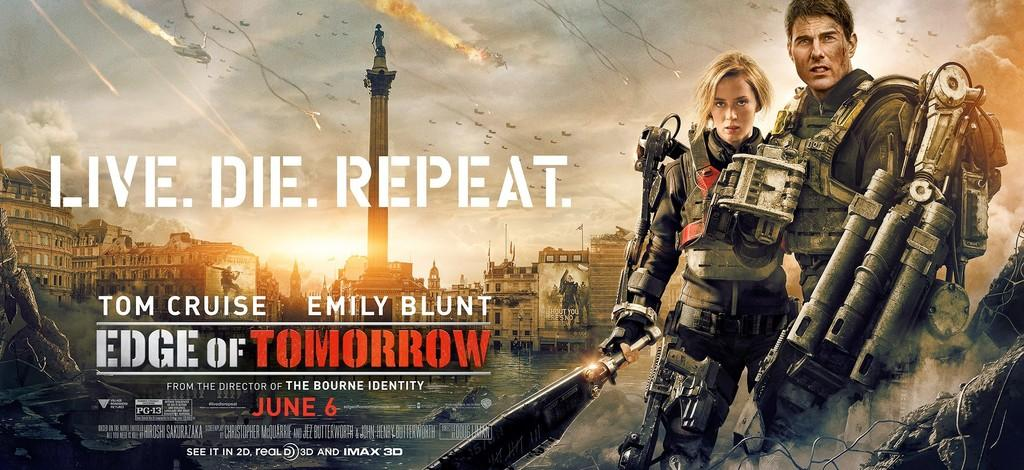<image>
Share a concise interpretation of the image provided. an image for a movie that is called Edge of Tomorrow 